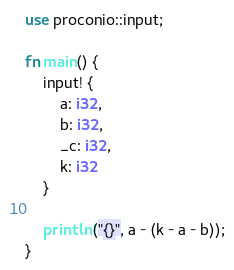Convert code to text. <code><loc_0><loc_0><loc_500><loc_500><_Rust_>use proconio::input;

fn main() {
    input! {
        a: i32,
        b: i32,
        _c: i32,
        k: i32
    }

    println!("{}", a - (k - a - b));
}
</code> 